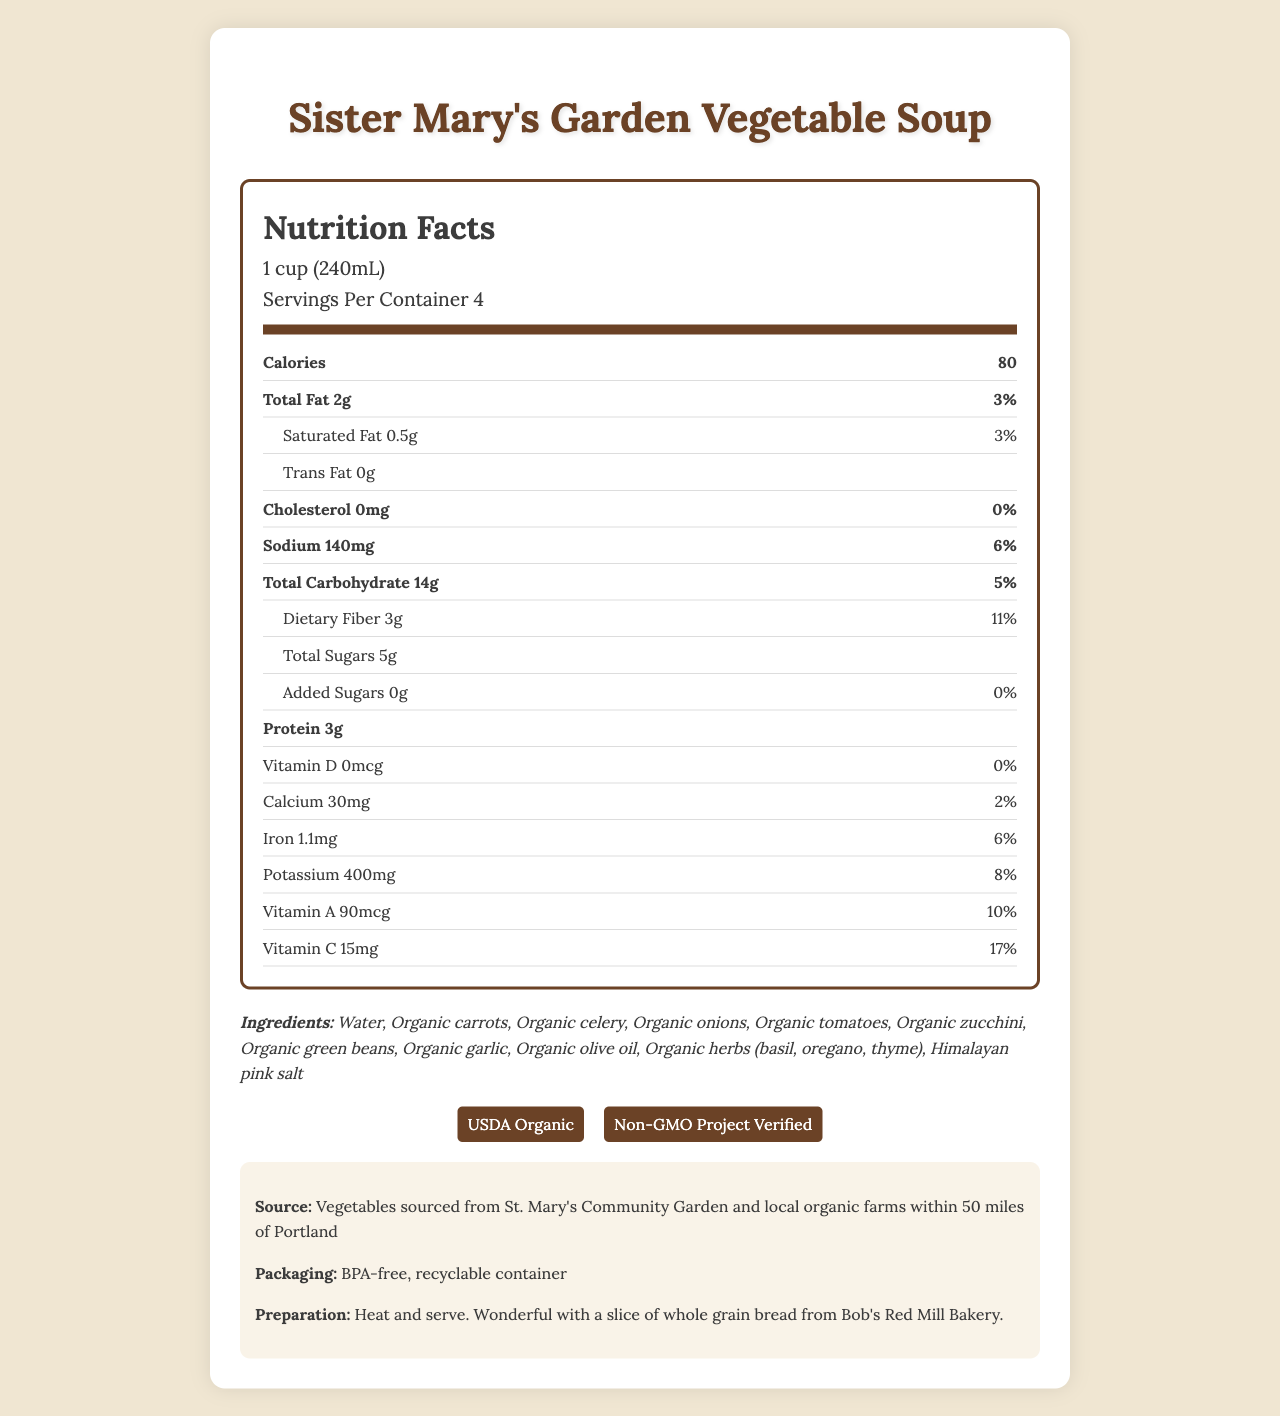what is the serving size? The serving size is explicitly mentioned under the nutrition header in the document.
Answer: 1 cup (240mL) how many servings are in a container? The number of servings per container is listed right below the serving size in the nutrition header.
Answer: 4 how much sodium is in one serving? The sodium content per serving is listed under the nutrition item for sodium.
Answer: 140mg what is the calorie count per serving? The calorie count is shown in bold at the beginning of the nutrition label section.
Answer: 80 how much protein does the soup contain per serving? The amount of protein per serving is listed under the bold nutrition item for protein.
Answer: 3g how much vitamin c does this soup provide in a serving? The amount of Vitamin C per serving is listed in the nutrition label.
Answer: 15mg what is the daily value percentage of dietary fiber in one serving? The daily value percentage for dietary fiber is specified alongside the amount of dietary fiber in the nutrition item section.
Answer: 11% how many ingredients are listed in the soup? There are 11 ingredients listed in the ingredients section.
Answer: 11 how much iron does this soup provide? A. 0.5mg B. 1.1mg C. 2.0mg D. 1.5mg The amount of iron per serving is listed as 1.1mg in the nutrition label.
Answer: B which certification does this soup hold? A. Gluten-Free B. USDA Organic C. Vegan The soup has the USDA Organic certification, as indicated in the certifications section.
Answer: B how many grams of added sugars are in the soup? The amount of added sugars per serving is listed as 0g in the nutrition item for added sugars.
Answer: 0g is the soup package recyclable? The packaging information states that it is a BPA-free, recyclable container.
Answer: Yes summarize the main points of the document The document contains a comprehensive nutrition facts label, a list of certifications, and additional contextual details about the product.
Answer: The document details the Nutrition Facts for Sister Mary's Garden Vegetable Soup, including serving size, calorie count, and nutrient information. It lists all the ingredients, allergen information, and certifications. Additionally, it provides information on the source of the vegetables, packaging, and preparation instructions. does the document state the amount of sugar in a whole container? The document provides the sugar content per serving but does not explicitly state the total amount for the entire container. To find the total amount, one would need to multiply the per-serving value (5g) by the number of servings (4). The label does not directly show this total.
Answer: No 